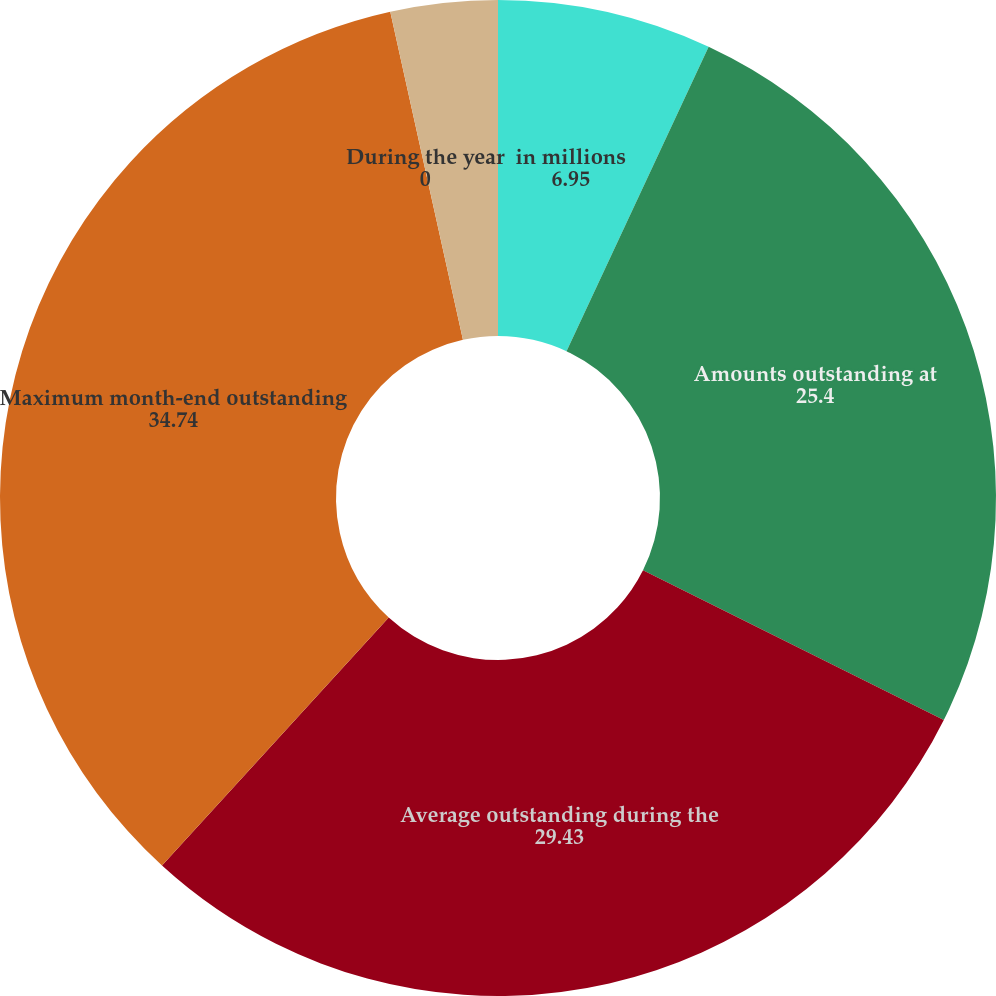Convert chart to OTSL. <chart><loc_0><loc_0><loc_500><loc_500><pie_chart><fcel>in millions<fcel>Amounts outstanding at<fcel>Average outstanding during the<fcel>Maximum month-end outstanding<fcel>During the year<fcel>At year-end<nl><fcel>6.95%<fcel>25.4%<fcel>29.43%<fcel>34.74%<fcel>0.0%<fcel>3.47%<nl></chart> 